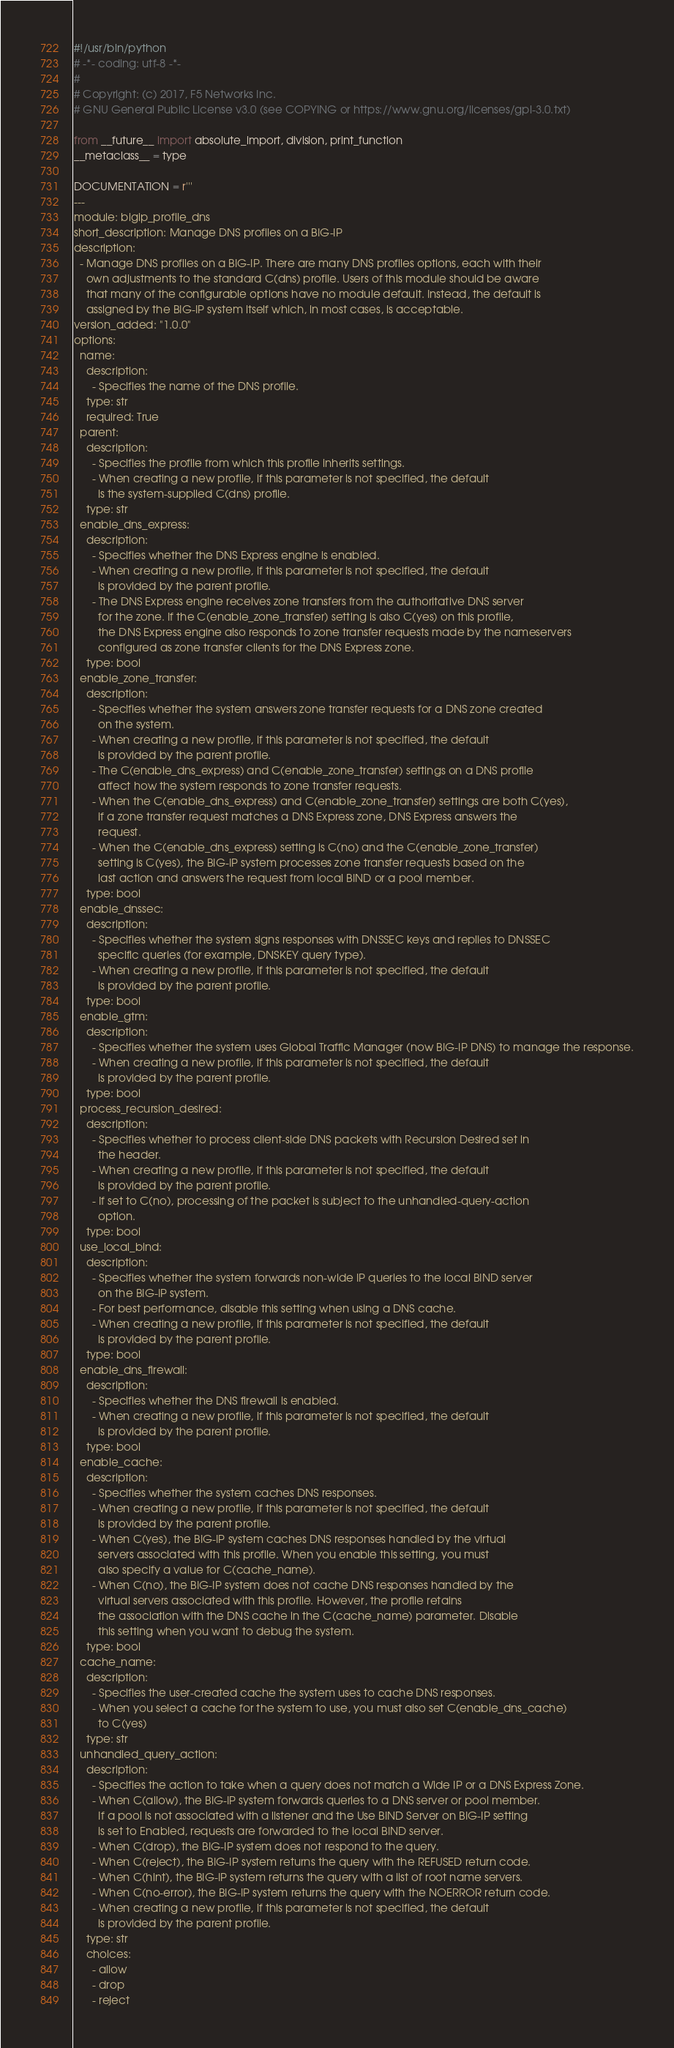<code> <loc_0><loc_0><loc_500><loc_500><_Python_>#!/usr/bin/python
# -*- coding: utf-8 -*-
#
# Copyright: (c) 2017, F5 Networks Inc.
# GNU General Public License v3.0 (see COPYING or https://www.gnu.org/licenses/gpl-3.0.txt)

from __future__ import absolute_import, division, print_function
__metaclass__ = type

DOCUMENTATION = r'''
---
module: bigip_profile_dns
short_description: Manage DNS profiles on a BIG-IP
description:
  - Manage DNS profiles on a BIG-IP. There are many DNS profiles options, each with their
    own adjustments to the standard C(dns) profile. Users of this module should be aware
    that many of the configurable options have no module default. Instead, the default is
    assigned by the BIG-IP system itself which, in most cases, is acceptable.
version_added: "1.0.0"
options:
  name:
    description:
      - Specifies the name of the DNS profile.
    type: str
    required: True
  parent:
    description:
      - Specifies the profile from which this profile inherits settings.
      - When creating a new profile, if this parameter is not specified, the default
        is the system-supplied C(dns) profile.
    type: str
  enable_dns_express:
    description:
      - Specifies whether the DNS Express engine is enabled.
      - When creating a new profile, if this parameter is not specified, the default
        is provided by the parent profile.
      - The DNS Express engine receives zone transfers from the authoritative DNS server
        for the zone. If the C(enable_zone_transfer) setting is also C(yes) on this profile,
        the DNS Express engine also responds to zone transfer requests made by the nameservers
        configured as zone transfer clients for the DNS Express zone.
    type: bool
  enable_zone_transfer:
    description:
      - Specifies whether the system answers zone transfer requests for a DNS zone created
        on the system.
      - When creating a new profile, if this parameter is not specified, the default
        is provided by the parent profile.
      - The C(enable_dns_express) and C(enable_zone_transfer) settings on a DNS profile
        affect how the system responds to zone transfer requests.
      - When the C(enable_dns_express) and C(enable_zone_transfer) settings are both C(yes),
        if a zone transfer request matches a DNS Express zone, DNS Express answers the
        request.
      - When the C(enable_dns_express) setting is C(no) and the C(enable_zone_transfer)
        setting is C(yes), the BIG-IP system processes zone transfer requests based on the
        last action and answers the request from local BIND or a pool member.
    type: bool
  enable_dnssec:
    description:
      - Specifies whether the system signs responses with DNSSEC keys and replies to DNSSEC
        specific queries (for example, DNSKEY query type).
      - When creating a new profile, if this parameter is not specified, the default
        is provided by the parent profile.
    type: bool
  enable_gtm:
    description:
      - Specifies whether the system uses Global Traffic Manager (now BIG-IP DNS) to manage the response.
      - When creating a new profile, if this parameter is not specified, the default
        is provided by the parent profile.
    type: bool
  process_recursion_desired:
    description:
      - Specifies whether to process client-side DNS packets with Recursion Desired set in
        the header.
      - When creating a new profile, if this parameter is not specified, the default
        is provided by the parent profile.
      - If set to C(no), processing of the packet is subject to the unhandled-query-action
        option.
    type: bool
  use_local_bind:
    description:
      - Specifies whether the system forwards non-wide IP queries to the local BIND server
        on the BIG-IP system.
      - For best performance, disable this setting when using a DNS cache.
      - When creating a new profile, if this parameter is not specified, the default
        is provided by the parent profile.
    type: bool
  enable_dns_firewall:
    description:
      - Specifies whether the DNS firewall is enabled.
      - When creating a new profile, if this parameter is not specified, the default
        is provided by the parent profile.
    type: bool
  enable_cache:
    description:
      - Specifies whether the system caches DNS responses.
      - When creating a new profile, if this parameter is not specified, the default
        is provided by the parent profile.
      - When C(yes), the BIG-IP system caches DNS responses handled by the virtual
        servers associated with this profile. When you enable this setting, you must
        also specify a value for C(cache_name).
      - When C(no), the BIG-IP system does not cache DNS responses handled by the
        virtual servers associated with this profile. However, the profile retains
        the association with the DNS cache in the C(cache_name) parameter. Disable
        this setting when you want to debug the system.
    type: bool
  cache_name:
    description:
      - Specifies the user-created cache the system uses to cache DNS responses.
      - When you select a cache for the system to use, you must also set C(enable_dns_cache)
        to C(yes)
    type: str
  unhandled_query_action:
    description:
      - Specifies the action to take when a query does not match a Wide IP or a DNS Express Zone.
      - When C(allow), the BIG-IP system forwards queries to a DNS server or pool member.
        If a pool is not associated with a listener and the Use BIND Server on BIG-IP setting
        is set to Enabled, requests are forwarded to the local BIND server.
      - When C(drop), the BIG-IP system does not respond to the query.
      - When C(reject), the BIG-IP system returns the query with the REFUSED return code.
      - When C(hint), the BIG-IP system returns the query with a list of root name servers.
      - When C(no-error), the BIG-IP system returns the query with the NOERROR return code.
      - When creating a new profile, if this parameter is not specified, the default
        is provided by the parent profile.
    type: str
    choices:
      - allow
      - drop
      - reject</code> 